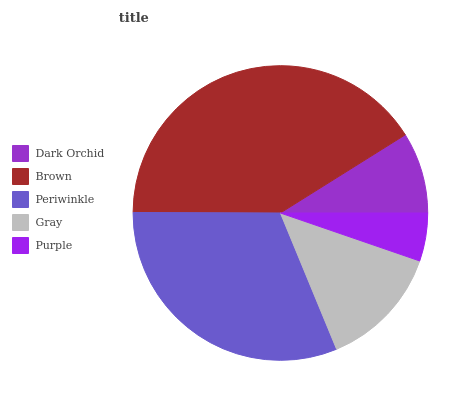Is Purple the minimum?
Answer yes or no. Yes. Is Brown the maximum?
Answer yes or no. Yes. Is Periwinkle the minimum?
Answer yes or no. No. Is Periwinkle the maximum?
Answer yes or no. No. Is Brown greater than Periwinkle?
Answer yes or no. Yes. Is Periwinkle less than Brown?
Answer yes or no. Yes. Is Periwinkle greater than Brown?
Answer yes or no. No. Is Brown less than Periwinkle?
Answer yes or no. No. Is Gray the high median?
Answer yes or no. Yes. Is Gray the low median?
Answer yes or no. Yes. Is Periwinkle the high median?
Answer yes or no. No. Is Dark Orchid the low median?
Answer yes or no. No. 